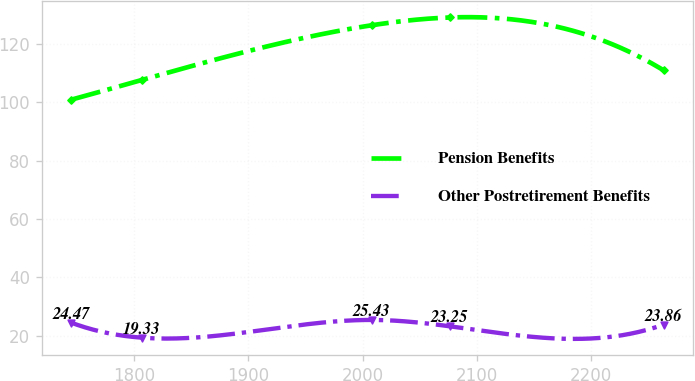<chart> <loc_0><loc_0><loc_500><loc_500><line_chart><ecel><fcel>Pension Benefits<fcel>Other Postretirement Benefits<nl><fcel>1745.27<fcel>100.95<fcel>24.47<nl><fcel>1807.44<fcel>107.75<fcel>19.33<nl><fcel>2008.55<fcel>126.48<fcel>25.43<nl><fcel>2076.28<fcel>129.11<fcel>23.25<nl><fcel>2263.53<fcel>110.94<fcel>23.86<nl></chart> 